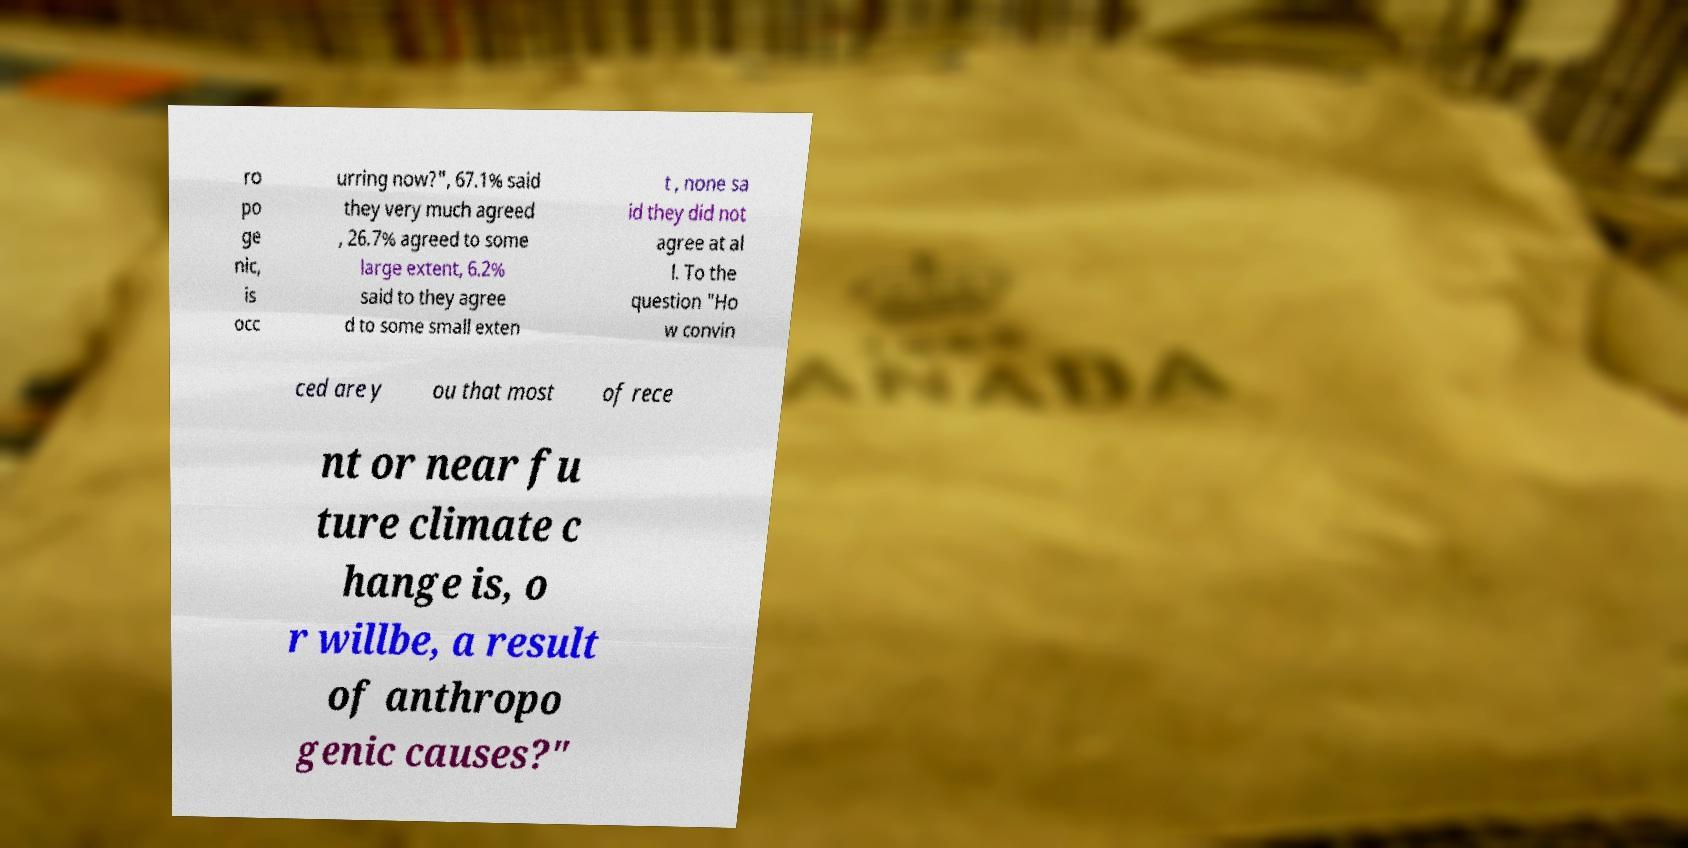Please read and relay the text visible in this image. What does it say? ro po ge nic, is occ urring now?", 67.1% said they very much agreed , 26.7% agreed to some large extent, 6.2% said to they agree d to some small exten t , none sa id they did not agree at al l. To the question "Ho w convin ced are y ou that most of rece nt or near fu ture climate c hange is, o r willbe, a result of anthropo genic causes?" 